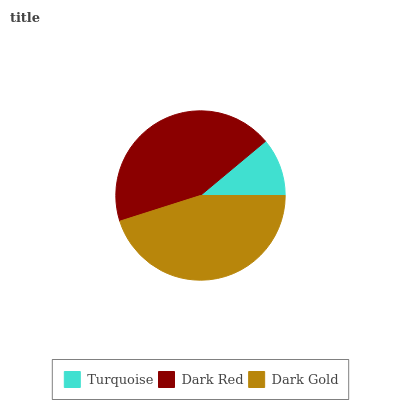Is Turquoise the minimum?
Answer yes or no. Yes. Is Dark Gold the maximum?
Answer yes or no. Yes. Is Dark Red the minimum?
Answer yes or no. No. Is Dark Red the maximum?
Answer yes or no. No. Is Dark Red greater than Turquoise?
Answer yes or no. Yes. Is Turquoise less than Dark Red?
Answer yes or no. Yes. Is Turquoise greater than Dark Red?
Answer yes or no. No. Is Dark Red less than Turquoise?
Answer yes or no. No. Is Dark Red the high median?
Answer yes or no. Yes. Is Dark Red the low median?
Answer yes or no. Yes. Is Turquoise the high median?
Answer yes or no. No. Is Dark Gold the low median?
Answer yes or no. No. 